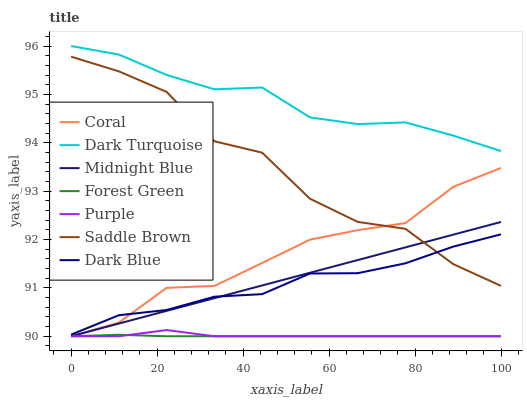Does Forest Green have the minimum area under the curve?
Answer yes or no. Yes. Does Dark Turquoise have the maximum area under the curve?
Answer yes or no. Yes. Does Purple have the minimum area under the curve?
Answer yes or no. No. Does Purple have the maximum area under the curve?
Answer yes or no. No. Is Midnight Blue the smoothest?
Answer yes or no. Yes. Is Saddle Brown the roughest?
Answer yes or no. Yes. Is Purple the smoothest?
Answer yes or no. No. Is Purple the roughest?
Answer yes or no. No. Does Midnight Blue have the lowest value?
Answer yes or no. Yes. Does Dark Turquoise have the lowest value?
Answer yes or no. No. Does Dark Turquoise have the highest value?
Answer yes or no. Yes. Does Purple have the highest value?
Answer yes or no. No. Is Forest Green less than Dark Blue?
Answer yes or no. Yes. Is Dark Turquoise greater than Dark Blue?
Answer yes or no. Yes. Does Coral intersect Purple?
Answer yes or no. Yes. Is Coral less than Purple?
Answer yes or no. No. Is Coral greater than Purple?
Answer yes or no. No. Does Forest Green intersect Dark Blue?
Answer yes or no. No. 